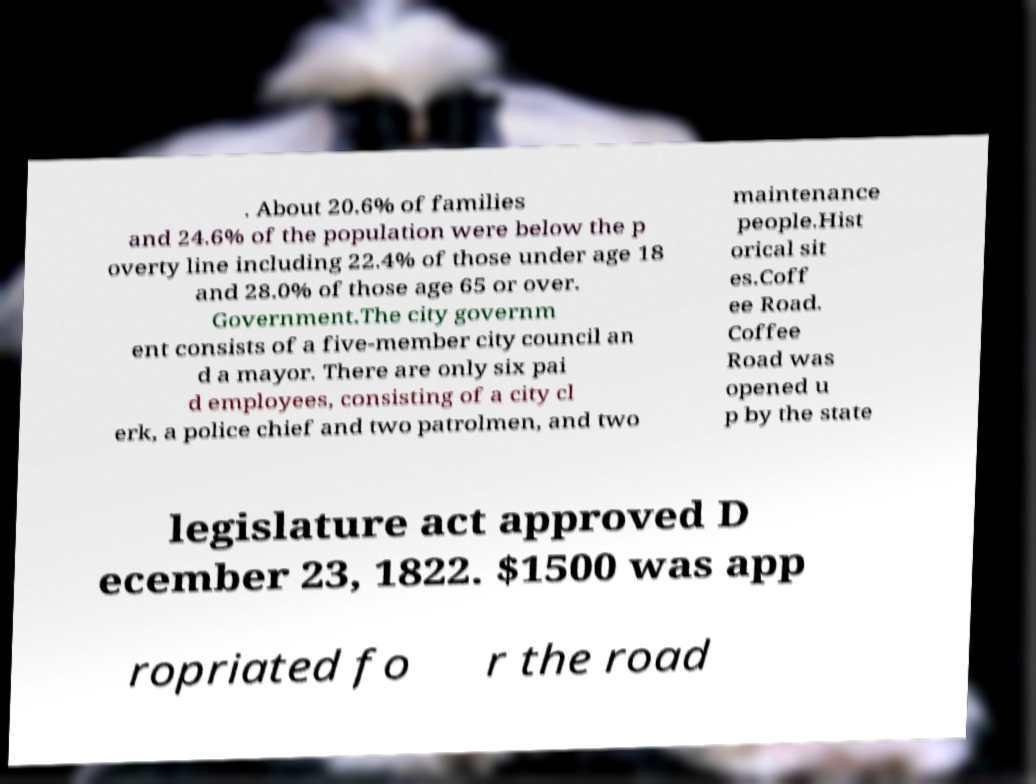What messages or text are displayed in this image? I need them in a readable, typed format. . About 20.6% of families and 24.6% of the population were below the p overty line including 22.4% of those under age 18 and 28.0% of those age 65 or over. Government.The city governm ent consists of a five-member city council an d a mayor. There are only six pai d employees, consisting of a city cl erk, a police chief and two patrolmen, and two maintenance people.Hist orical sit es.Coff ee Road. Coffee Road was opened u p by the state legislature act approved D ecember 23, 1822. $1500 was app ropriated fo r the road 